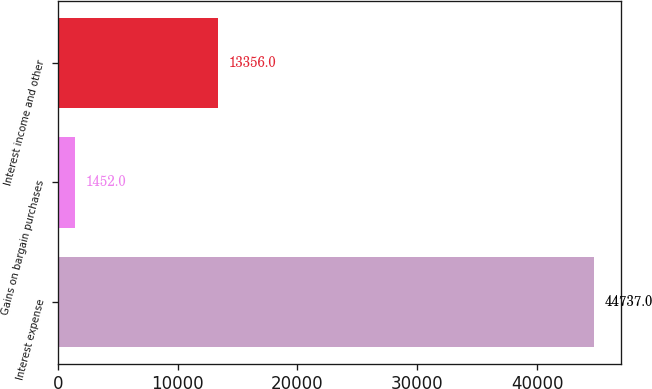<chart> <loc_0><loc_0><loc_500><loc_500><bar_chart><fcel>Interest expense<fcel>Gains on bargain purchases<fcel>Interest income and other<nl><fcel>44737<fcel>1452<fcel>13356<nl></chart> 